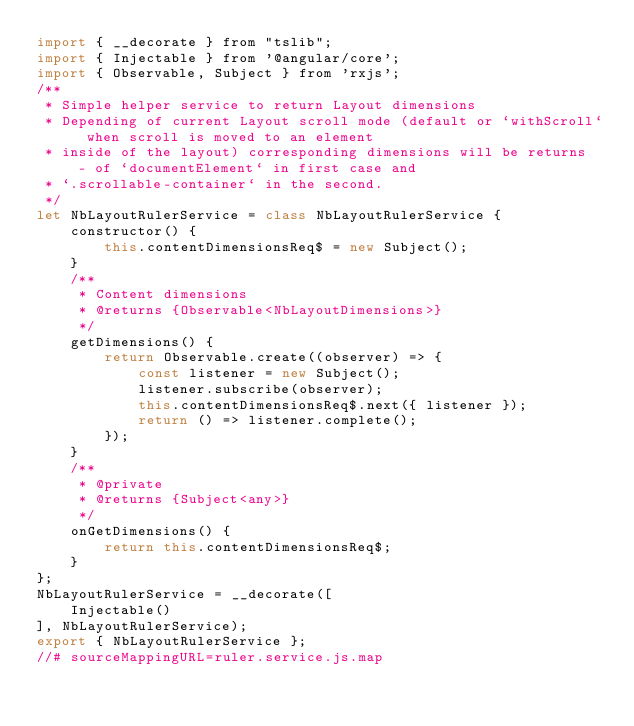Convert code to text. <code><loc_0><loc_0><loc_500><loc_500><_JavaScript_>import { __decorate } from "tslib";
import { Injectable } from '@angular/core';
import { Observable, Subject } from 'rxjs';
/**
 * Simple helper service to return Layout dimensions
 * Depending of current Layout scroll mode (default or `withScroll` when scroll is moved to an element
 * inside of the layout) corresponding dimensions will be returns  - of `documentElement` in first case and
 * `.scrollable-container` in the second.
 */
let NbLayoutRulerService = class NbLayoutRulerService {
    constructor() {
        this.contentDimensionsReq$ = new Subject();
    }
    /**
     * Content dimensions
     * @returns {Observable<NbLayoutDimensions>}
     */
    getDimensions() {
        return Observable.create((observer) => {
            const listener = new Subject();
            listener.subscribe(observer);
            this.contentDimensionsReq$.next({ listener });
            return () => listener.complete();
        });
    }
    /**
     * @private
     * @returns {Subject<any>}
     */
    onGetDimensions() {
        return this.contentDimensionsReq$;
    }
};
NbLayoutRulerService = __decorate([
    Injectable()
], NbLayoutRulerService);
export { NbLayoutRulerService };
//# sourceMappingURL=ruler.service.js.map</code> 